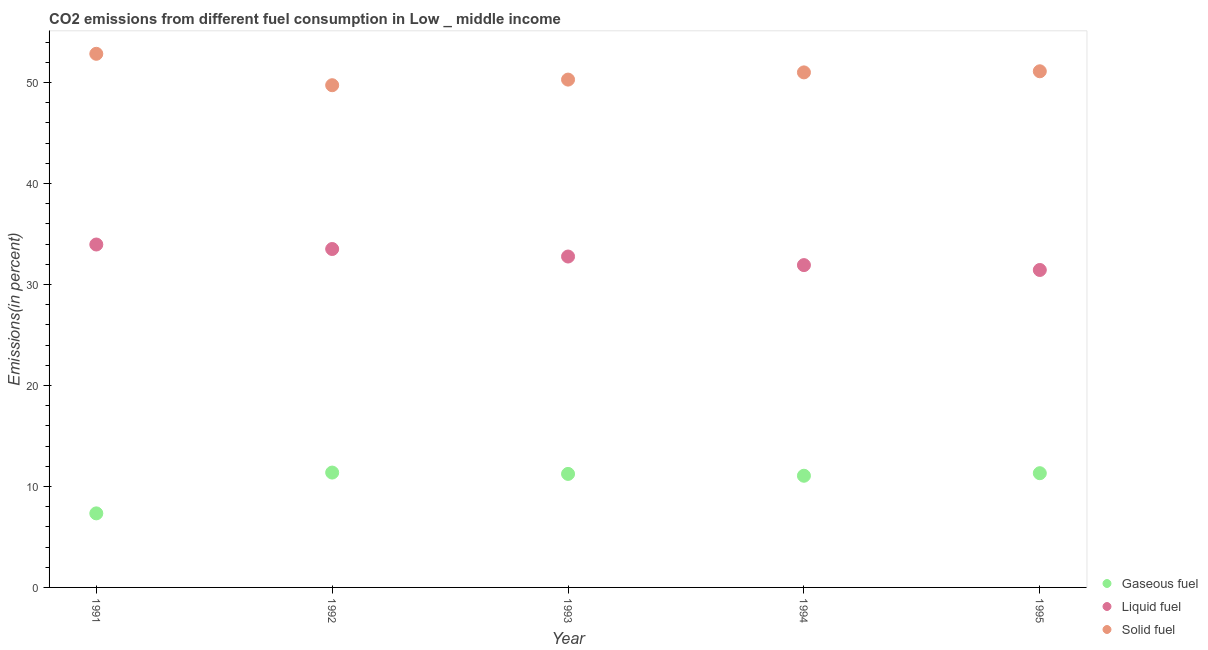How many different coloured dotlines are there?
Provide a succinct answer. 3. Is the number of dotlines equal to the number of legend labels?
Ensure brevity in your answer.  Yes. What is the percentage of solid fuel emission in 1993?
Provide a short and direct response. 50.29. Across all years, what is the maximum percentage of solid fuel emission?
Give a very brief answer. 52.84. Across all years, what is the minimum percentage of solid fuel emission?
Give a very brief answer. 49.73. In which year was the percentage of gaseous fuel emission maximum?
Ensure brevity in your answer.  1992. In which year was the percentage of liquid fuel emission minimum?
Keep it short and to the point. 1995. What is the total percentage of solid fuel emission in the graph?
Your response must be concise. 254.96. What is the difference between the percentage of solid fuel emission in 1993 and that in 1994?
Your answer should be very brief. -0.71. What is the difference between the percentage of solid fuel emission in 1992 and the percentage of liquid fuel emission in 1991?
Ensure brevity in your answer.  15.77. What is the average percentage of gaseous fuel emission per year?
Offer a very short reply. 10.46. In the year 1991, what is the difference between the percentage of gaseous fuel emission and percentage of solid fuel emission?
Your answer should be compact. -45.51. What is the ratio of the percentage of gaseous fuel emission in 1994 to that in 1995?
Your answer should be compact. 0.98. Is the percentage of solid fuel emission in 1991 less than that in 1994?
Ensure brevity in your answer.  No. What is the difference between the highest and the second highest percentage of gaseous fuel emission?
Ensure brevity in your answer.  0.06. What is the difference between the highest and the lowest percentage of liquid fuel emission?
Provide a short and direct response. 2.52. In how many years, is the percentage of gaseous fuel emission greater than the average percentage of gaseous fuel emission taken over all years?
Give a very brief answer. 4. Is the sum of the percentage of gaseous fuel emission in 1993 and 1995 greater than the maximum percentage of solid fuel emission across all years?
Your answer should be compact. No. Is the percentage of gaseous fuel emission strictly less than the percentage of liquid fuel emission over the years?
Provide a succinct answer. Yes. How many years are there in the graph?
Provide a succinct answer. 5. What is the difference between two consecutive major ticks on the Y-axis?
Your response must be concise. 10. Are the values on the major ticks of Y-axis written in scientific E-notation?
Your response must be concise. No. What is the title of the graph?
Provide a succinct answer. CO2 emissions from different fuel consumption in Low _ middle income. What is the label or title of the Y-axis?
Offer a very short reply. Emissions(in percent). What is the Emissions(in percent) of Gaseous fuel in 1991?
Provide a succinct answer. 7.33. What is the Emissions(in percent) of Liquid fuel in 1991?
Your answer should be compact. 33.96. What is the Emissions(in percent) in Solid fuel in 1991?
Make the answer very short. 52.84. What is the Emissions(in percent) in Gaseous fuel in 1992?
Your response must be concise. 11.37. What is the Emissions(in percent) in Liquid fuel in 1992?
Your response must be concise. 33.51. What is the Emissions(in percent) of Solid fuel in 1992?
Give a very brief answer. 49.73. What is the Emissions(in percent) of Gaseous fuel in 1993?
Keep it short and to the point. 11.24. What is the Emissions(in percent) of Liquid fuel in 1993?
Your response must be concise. 32.77. What is the Emissions(in percent) in Solid fuel in 1993?
Keep it short and to the point. 50.29. What is the Emissions(in percent) in Gaseous fuel in 1994?
Your response must be concise. 11.06. What is the Emissions(in percent) of Liquid fuel in 1994?
Your answer should be compact. 31.92. What is the Emissions(in percent) in Solid fuel in 1994?
Keep it short and to the point. 51. What is the Emissions(in percent) in Gaseous fuel in 1995?
Make the answer very short. 11.31. What is the Emissions(in percent) in Liquid fuel in 1995?
Ensure brevity in your answer.  31.43. What is the Emissions(in percent) of Solid fuel in 1995?
Provide a short and direct response. 51.11. Across all years, what is the maximum Emissions(in percent) of Gaseous fuel?
Keep it short and to the point. 11.37. Across all years, what is the maximum Emissions(in percent) in Liquid fuel?
Give a very brief answer. 33.96. Across all years, what is the maximum Emissions(in percent) in Solid fuel?
Give a very brief answer. 52.84. Across all years, what is the minimum Emissions(in percent) in Gaseous fuel?
Your answer should be very brief. 7.33. Across all years, what is the minimum Emissions(in percent) in Liquid fuel?
Offer a very short reply. 31.43. Across all years, what is the minimum Emissions(in percent) of Solid fuel?
Offer a very short reply. 49.73. What is the total Emissions(in percent) in Gaseous fuel in the graph?
Offer a terse response. 52.32. What is the total Emissions(in percent) of Liquid fuel in the graph?
Give a very brief answer. 163.58. What is the total Emissions(in percent) in Solid fuel in the graph?
Make the answer very short. 254.96. What is the difference between the Emissions(in percent) in Gaseous fuel in 1991 and that in 1992?
Provide a succinct answer. -4.04. What is the difference between the Emissions(in percent) of Liquid fuel in 1991 and that in 1992?
Your response must be concise. 0.45. What is the difference between the Emissions(in percent) of Solid fuel in 1991 and that in 1992?
Keep it short and to the point. 3.11. What is the difference between the Emissions(in percent) of Gaseous fuel in 1991 and that in 1993?
Your answer should be very brief. -3.91. What is the difference between the Emissions(in percent) in Liquid fuel in 1991 and that in 1993?
Offer a very short reply. 1.19. What is the difference between the Emissions(in percent) of Solid fuel in 1991 and that in 1993?
Ensure brevity in your answer.  2.55. What is the difference between the Emissions(in percent) of Gaseous fuel in 1991 and that in 1994?
Keep it short and to the point. -3.73. What is the difference between the Emissions(in percent) of Liquid fuel in 1991 and that in 1994?
Your response must be concise. 2.04. What is the difference between the Emissions(in percent) in Solid fuel in 1991 and that in 1994?
Ensure brevity in your answer.  1.84. What is the difference between the Emissions(in percent) in Gaseous fuel in 1991 and that in 1995?
Ensure brevity in your answer.  -3.98. What is the difference between the Emissions(in percent) in Liquid fuel in 1991 and that in 1995?
Ensure brevity in your answer.  2.52. What is the difference between the Emissions(in percent) in Solid fuel in 1991 and that in 1995?
Offer a terse response. 1.73. What is the difference between the Emissions(in percent) in Gaseous fuel in 1992 and that in 1993?
Your answer should be compact. 0.13. What is the difference between the Emissions(in percent) in Liquid fuel in 1992 and that in 1993?
Your answer should be compact. 0.74. What is the difference between the Emissions(in percent) in Solid fuel in 1992 and that in 1993?
Make the answer very short. -0.56. What is the difference between the Emissions(in percent) in Gaseous fuel in 1992 and that in 1994?
Provide a succinct answer. 0.32. What is the difference between the Emissions(in percent) in Liquid fuel in 1992 and that in 1994?
Offer a very short reply. 1.59. What is the difference between the Emissions(in percent) in Solid fuel in 1992 and that in 1994?
Offer a very short reply. -1.27. What is the difference between the Emissions(in percent) in Gaseous fuel in 1992 and that in 1995?
Offer a terse response. 0.06. What is the difference between the Emissions(in percent) of Liquid fuel in 1992 and that in 1995?
Give a very brief answer. 2.08. What is the difference between the Emissions(in percent) of Solid fuel in 1992 and that in 1995?
Make the answer very short. -1.38. What is the difference between the Emissions(in percent) of Gaseous fuel in 1993 and that in 1994?
Your answer should be compact. 0.18. What is the difference between the Emissions(in percent) in Liquid fuel in 1993 and that in 1994?
Provide a short and direct response. 0.85. What is the difference between the Emissions(in percent) in Solid fuel in 1993 and that in 1994?
Offer a very short reply. -0.71. What is the difference between the Emissions(in percent) of Gaseous fuel in 1993 and that in 1995?
Your answer should be very brief. -0.07. What is the difference between the Emissions(in percent) in Liquid fuel in 1993 and that in 1995?
Offer a terse response. 1.33. What is the difference between the Emissions(in percent) of Solid fuel in 1993 and that in 1995?
Your answer should be compact. -0.82. What is the difference between the Emissions(in percent) in Gaseous fuel in 1994 and that in 1995?
Offer a very short reply. -0.25. What is the difference between the Emissions(in percent) of Liquid fuel in 1994 and that in 1995?
Ensure brevity in your answer.  0.48. What is the difference between the Emissions(in percent) in Solid fuel in 1994 and that in 1995?
Provide a short and direct response. -0.11. What is the difference between the Emissions(in percent) in Gaseous fuel in 1991 and the Emissions(in percent) in Liquid fuel in 1992?
Provide a succinct answer. -26.18. What is the difference between the Emissions(in percent) in Gaseous fuel in 1991 and the Emissions(in percent) in Solid fuel in 1992?
Provide a short and direct response. -42.4. What is the difference between the Emissions(in percent) in Liquid fuel in 1991 and the Emissions(in percent) in Solid fuel in 1992?
Make the answer very short. -15.77. What is the difference between the Emissions(in percent) in Gaseous fuel in 1991 and the Emissions(in percent) in Liquid fuel in 1993?
Your answer should be compact. -25.43. What is the difference between the Emissions(in percent) of Gaseous fuel in 1991 and the Emissions(in percent) of Solid fuel in 1993?
Keep it short and to the point. -42.95. What is the difference between the Emissions(in percent) in Liquid fuel in 1991 and the Emissions(in percent) in Solid fuel in 1993?
Make the answer very short. -16.33. What is the difference between the Emissions(in percent) of Gaseous fuel in 1991 and the Emissions(in percent) of Liquid fuel in 1994?
Keep it short and to the point. -24.58. What is the difference between the Emissions(in percent) of Gaseous fuel in 1991 and the Emissions(in percent) of Solid fuel in 1994?
Make the answer very short. -43.67. What is the difference between the Emissions(in percent) in Liquid fuel in 1991 and the Emissions(in percent) in Solid fuel in 1994?
Your response must be concise. -17.04. What is the difference between the Emissions(in percent) of Gaseous fuel in 1991 and the Emissions(in percent) of Liquid fuel in 1995?
Give a very brief answer. -24.1. What is the difference between the Emissions(in percent) of Gaseous fuel in 1991 and the Emissions(in percent) of Solid fuel in 1995?
Make the answer very short. -43.78. What is the difference between the Emissions(in percent) in Liquid fuel in 1991 and the Emissions(in percent) in Solid fuel in 1995?
Your response must be concise. -17.15. What is the difference between the Emissions(in percent) of Gaseous fuel in 1992 and the Emissions(in percent) of Liquid fuel in 1993?
Offer a terse response. -21.39. What is the difference between the Emissions(in percent) in Gaseous fuel in 1992 and the Emissions(in percent) in Solid fuel in 1993?
Give a very brief answer. -38.91. What is the difference between the Emissions(in percent) of Liquid fuel in 1992 and the Emissions(in percent) of Solid fuel in 1993?
Give a very brief answer. -16.78. What is the difference between the Emissions(in percent) of Gaseous fuel in 1992 and the Emissions(in percent) of Liquid fuel in 1994?
Ensure brevity in your answer.  -20.54. What is the difference between the Emissions(in percent) in Gaseous fuel in 1992 and the Emissions(in percent) in Solid fuel in 1994?
Keep it short and to the point. -39.63. What is the difference between the Emissions(in percent) in Liquid fuel in 1992 and the Emissions(in percent) in Solid fuel in 1994?
Offer a very short reply. -17.49. What is the difference between the Emissions(in percent) in Gaseous fuel in 1992 and the Emissions(in percent) in Liquid fuel in 1995?
Keep it short and to the point. -20.06. What is the difference between the Emissions(in percent) of Gaseous fuel in 1992 and the Emissions(in percent) of Solid fuel in 1995?
Your answer should be compact. -39.74. What is the difference between the Emissions(in percent) of Liquid fuel in 1992 and the Emissions(in percent) of Solid fuel in 1995?
Offer a terse response. -17.6. What is the difference between the Emissions(in percent) of Gaseous fuel in 1993 and the Emissions(in percent) of Liquid fuel in 1994?
Keep it short and to the point. -20.68. What is the difference between the Emissions(in percent) in Gaseous fuel in 1993 and the Emissions(in percent) in Solid fuel in 1994?
Your response must be concise. -39.76. What is the difference between the Emissions(in percent) of Liquid fuel in 1993 and the Emissions(in percent) of Solid fuel in 1994?
Ensure brevity in your answer.  -18.23. What is the difference between the Emissions(in percent) of Gaseous fuel in 1993 and the Emissions(in percent) of Liquid fuel in 1995?
Provide a succinct answer. -20.19. What is the difference between the Emissions(in percent) of Gaseous fuel in 1993 and the Emissions(in percent) of Solid fuel in 1995?
Your answer should be very brief. -39.87. What is the difference between the Emissions(in percent) in Liquid fuel in 1993 and the Emissions(in percent) in Solid fuel in 1995?
Give a very brief answer. -18.34. What is the difference between the Emissions(in percent) of Gaseous fuel in 1994 and the Emissions(in percent) of Liquid fuel in 1995?
Keep it short and to the point. -20.38. What is the difference between the Emissions(in percent) in Gaseous fuel in 1994 and the Emissions(in percent) in Solid fuel in 1995?
Keep it short and to the point. -40.05. What is the difference between the Emissions(in percent) of Liquid fuel in 1994 and the Emissions(in percent) of Solid fuel in 1995?
Offer a terse response. -19.19. What is the average Emissions(in percent) of Gaseous fuel per year?
Provide a short and direct response. 10.46. What is the average Emissions(in percent) in Liquid fuel per year?
Provide a short and direct response. 32.72. What is the average Emissions(in percent) in Solid fuel per year?
Your answer should be compact. 50.99. In the year 1991, what is the difference between the Emissions(in percent) of Gaseous fuel and Emissions(in percent) of Liquid fuel?
Provide a short and direct response. -26.62. In the year 1991, what is the difference between the Emissions(in percent) in Gaseous fuel and Emissions(in percent) in Solid fuel?
Your answer should be very brief. -45.51. In the year 1991, what is the difference between the Emissions(in percent) of Liquid fuel and Emissions(in percent) of Solid fuel?
Provide a succinct answer. -18.88. In the year 1992, what is the difference between the Emissions(in percent) in Gaseous fuel and Emissions(in percent) in Liquid fuel?
Offer a terse response. -22.14. In the year 1992, what is the difference between the Emissions(in percent) of Gaseous fuel and Emissions(in percent) of Solid fuel?
Your answer should be very brief. -38.36. In the year 1992, what is the difference between the Emissions(in percent) of Liquid fuel and Emissions(in percent) of Solid fuel?
Ensure brevity in your answer.  -16.22. In the year 1993, what is the difference between the Emissions(in percent) in Gaseous fuel and Emissions(in percent) in Liquid fuel?
Give a very brief answer. -21.53. In the year 1993, what is the difference between the Emissions(in percent) of Gaseous fuel and Emissions(in percent) of Solid fuel?
Your response must be concise. -39.05. In the year 1993, what is the difference between the Emissions(in percent) in Liquid fuel and Emissions(in percent) in Solid fuel?
Provide a short and direct response. -17.52. In the year 1994, what is the difference between the Emissions(in percent) in Gaseous fuel and Emissions(in percent) in Liquid fuel?
Offer a very short reply. -20.86. In the year 1994, what is the difference between the Emissions(in percent) of Gaseous fuel and Emissions(in percent) of Solid fuel?
Offer a very short reply. -39.94. In the year 1994, what is the difference between the Emissions(in percent) of Liquid fuel and Emissions(in percent) of Solid fuel?
Keep it short and to the point. -19.08. In the year 1995, what is the difference between the Emissions(in percent) in Gaseous fuel and Emissions(in percent) in Liquid fuel?
Your answer should be compact. -20.12. In the year 1995, what is the difference between the Emissions(in percent) of Gaseous fuel and Emissions(in percent) of Solid fuel?
Provide a succinct answer. -39.8. In the year 1995, what is the difference between the Emissions(in percent) of Liquid fuel and Emissions(in percent) of Solid fuel?
Ensure brevity in your answer.  -19.67. What is the ratio of the Emissions(in percent) of Gaseous fuel in 1991 to that in 1992?
Offer a terse response. 0.64. What is the ratio of the Emissions(in percent) of Liquid fuel in 1991 to that in 1992?
Your answer should be compact. 1.01. What is the ratio of the Emissions(in percent) in Gaseous fuel in 1991 to that in 1993?
Keep it short and to the point. 0.65. What is the ratio of the Emissions(in percent) of Liquid fuel in 1991 to that in 1993?
Keep it short and to the point. 1.04. What is the ratio of the Emissions(in percent) in Solid fuel in 1991 to that in 1993?
Provide a short and direct response. 1.05. What is the ratio of the Emissions(in percent) of Gaseous fuel in 1991 to that in 1994?
Keep it short and to the point. 0.66. What is the ratio of the Emissions(in percent) of Liquid fuel in 1991 to that in 1994?
Your response must be concise. 1.06. What is the ratio of the Emissions(in percent) of Solid fuel in 1991 to that in 1994?
Provide a succinct answer. 1.04. What is the ratio of the Emissions(in percent) of Gaseous fuel in 1991 to that in 1995?
Provide a succinct answer. 0.65. What is the ratio of the Emissions(in percent) in Liquid fuel in 1991 to that in 1995?
Provide a short and direct response. 1.08. What is the ratio of the Emissions(in percent) of Solid fuel in 1991 to that in 1995?
Offer a terse response. 1.03. What is the ratio of the Emissions(in percent) of Gaseous fuel in 1992 to that in 1993?
Your response must be concise. 1.01. What is the ratio of the Emissions(in percent) of Liquid fuel in 1992 to that in 1993?
Ensure brevity in your answer.  1.02. What is the ratio of the Emissions(in percent) of Solid fuel in 1992 to that in 1993?
Your response must be concise. 0.99. What is the ratio of the Emissions(in percent) of Gaseous fuel in 1992 to that in 1994?
Offer a very short reply. 1.03. What is the ratio of the Emissions(in percent) of Solid fuel in 1992 to that in 1994?
Your answer should be compact. 0.98. What is the ratio of the Emissions(in percent) of Liquid fuel in 1992 to that in 1995?
Give a very brief answer. 1.07. What is the ratio of the Emissions(in percent) of Gaseous fuel in 1993 to that in 1994?
Offer a terse response. 1.02. What is the ratio of the Emissions(in percent) of Liquid fuel in 1993 to that in 1994?
Your answer should be very brief. 1.03. What is the ratio of the Emissions(in percent) in Liquid fuel in 1993 to that in 1995?
Provide a short and direct response. 1.04. What is the ratio of the Emissions(in percent) of Solid fuel in 1993 to that in 1995?
Provide a succinct answer. 0.98. What is the ratio of the Emissions(in percent) of Gaseous fuel in 1994 to that in 1995?
Keep it short and to the point. 0.98. What is the ratio of the Emissions(in percent) of Liquid fuel in 1994 to that in 1995?
Provide a short and direct response. 1.02. What is the difference between the highest and the second highest Emissions(in percent) of Gaseous fuel?
Provide a short and direct response. 0.06. What is the difference between the highest and the second highest Emissions(in percent) of Liquid fuel?
Ensure brevity in your answer.  0.45. What is the difference between the highest and the second highest Emissions(in percent) in Solid fuel?
Your response must be concise. 1.73. What is the difference between the highest and the lowest Emissions(in percent) of Gaseous fuel?
Offer a very short reply. 4.04. What is the difference between the highest and the lowest Emissions(in percent) of Liquid fuel?
Offer a very short reply. 2.52. What is the difference between the highest and the lowest Emissions(in percent) in Solid fuel?
Provide a succinct answer. 3.11. 